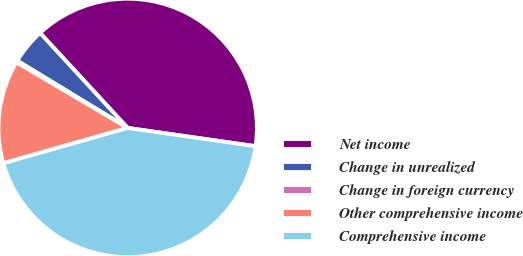Convert chart. <chart><loc_0><loc_0><loc_500><loc_500><pie_chart><fcel>Net income<fcel>Change in unrealized<fcel>Change in foreign currency<fcel>Other comprehensive income<fcel>Comprehensive income<nl><fcel>39.11%<fcel>4.44%<fcel>0.22%<fcel>12.89%<fcel>43.33%<nl></chart> 